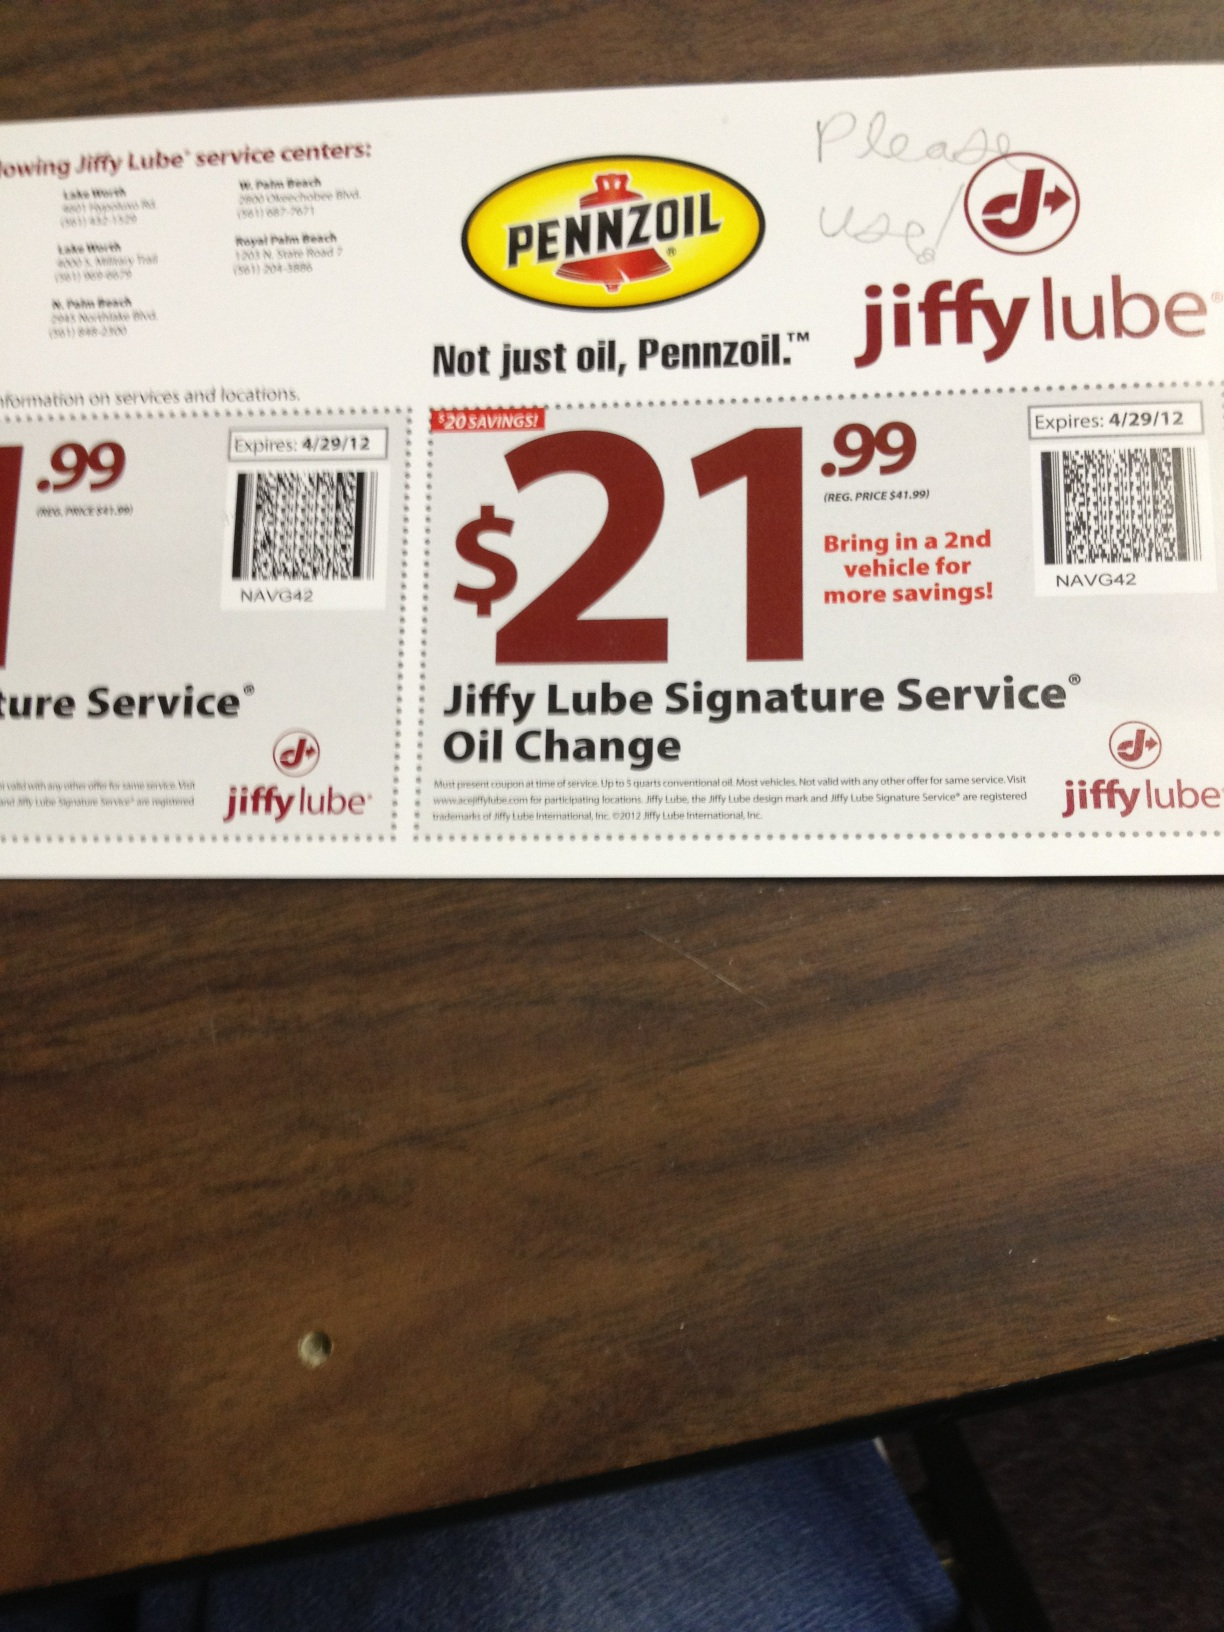Can you provide details about the Jiffy Lube Signature Service? The Jiffy Lube Signature Service Oil Change typically includes a comprehensive oil change with up to 5 quarts of quality motor oil and a new oil filter. Additionally, it includes checking and topping off essential fluids, such as transmission, differential/transfer case, power steering, battery, and windshield washer fluid. The service often also involves checking and adjusting tire pressure, cleaning exterior windows, vacuuming interior floors, and inspecting key components, helping to keep your vehicle running smoothly. 